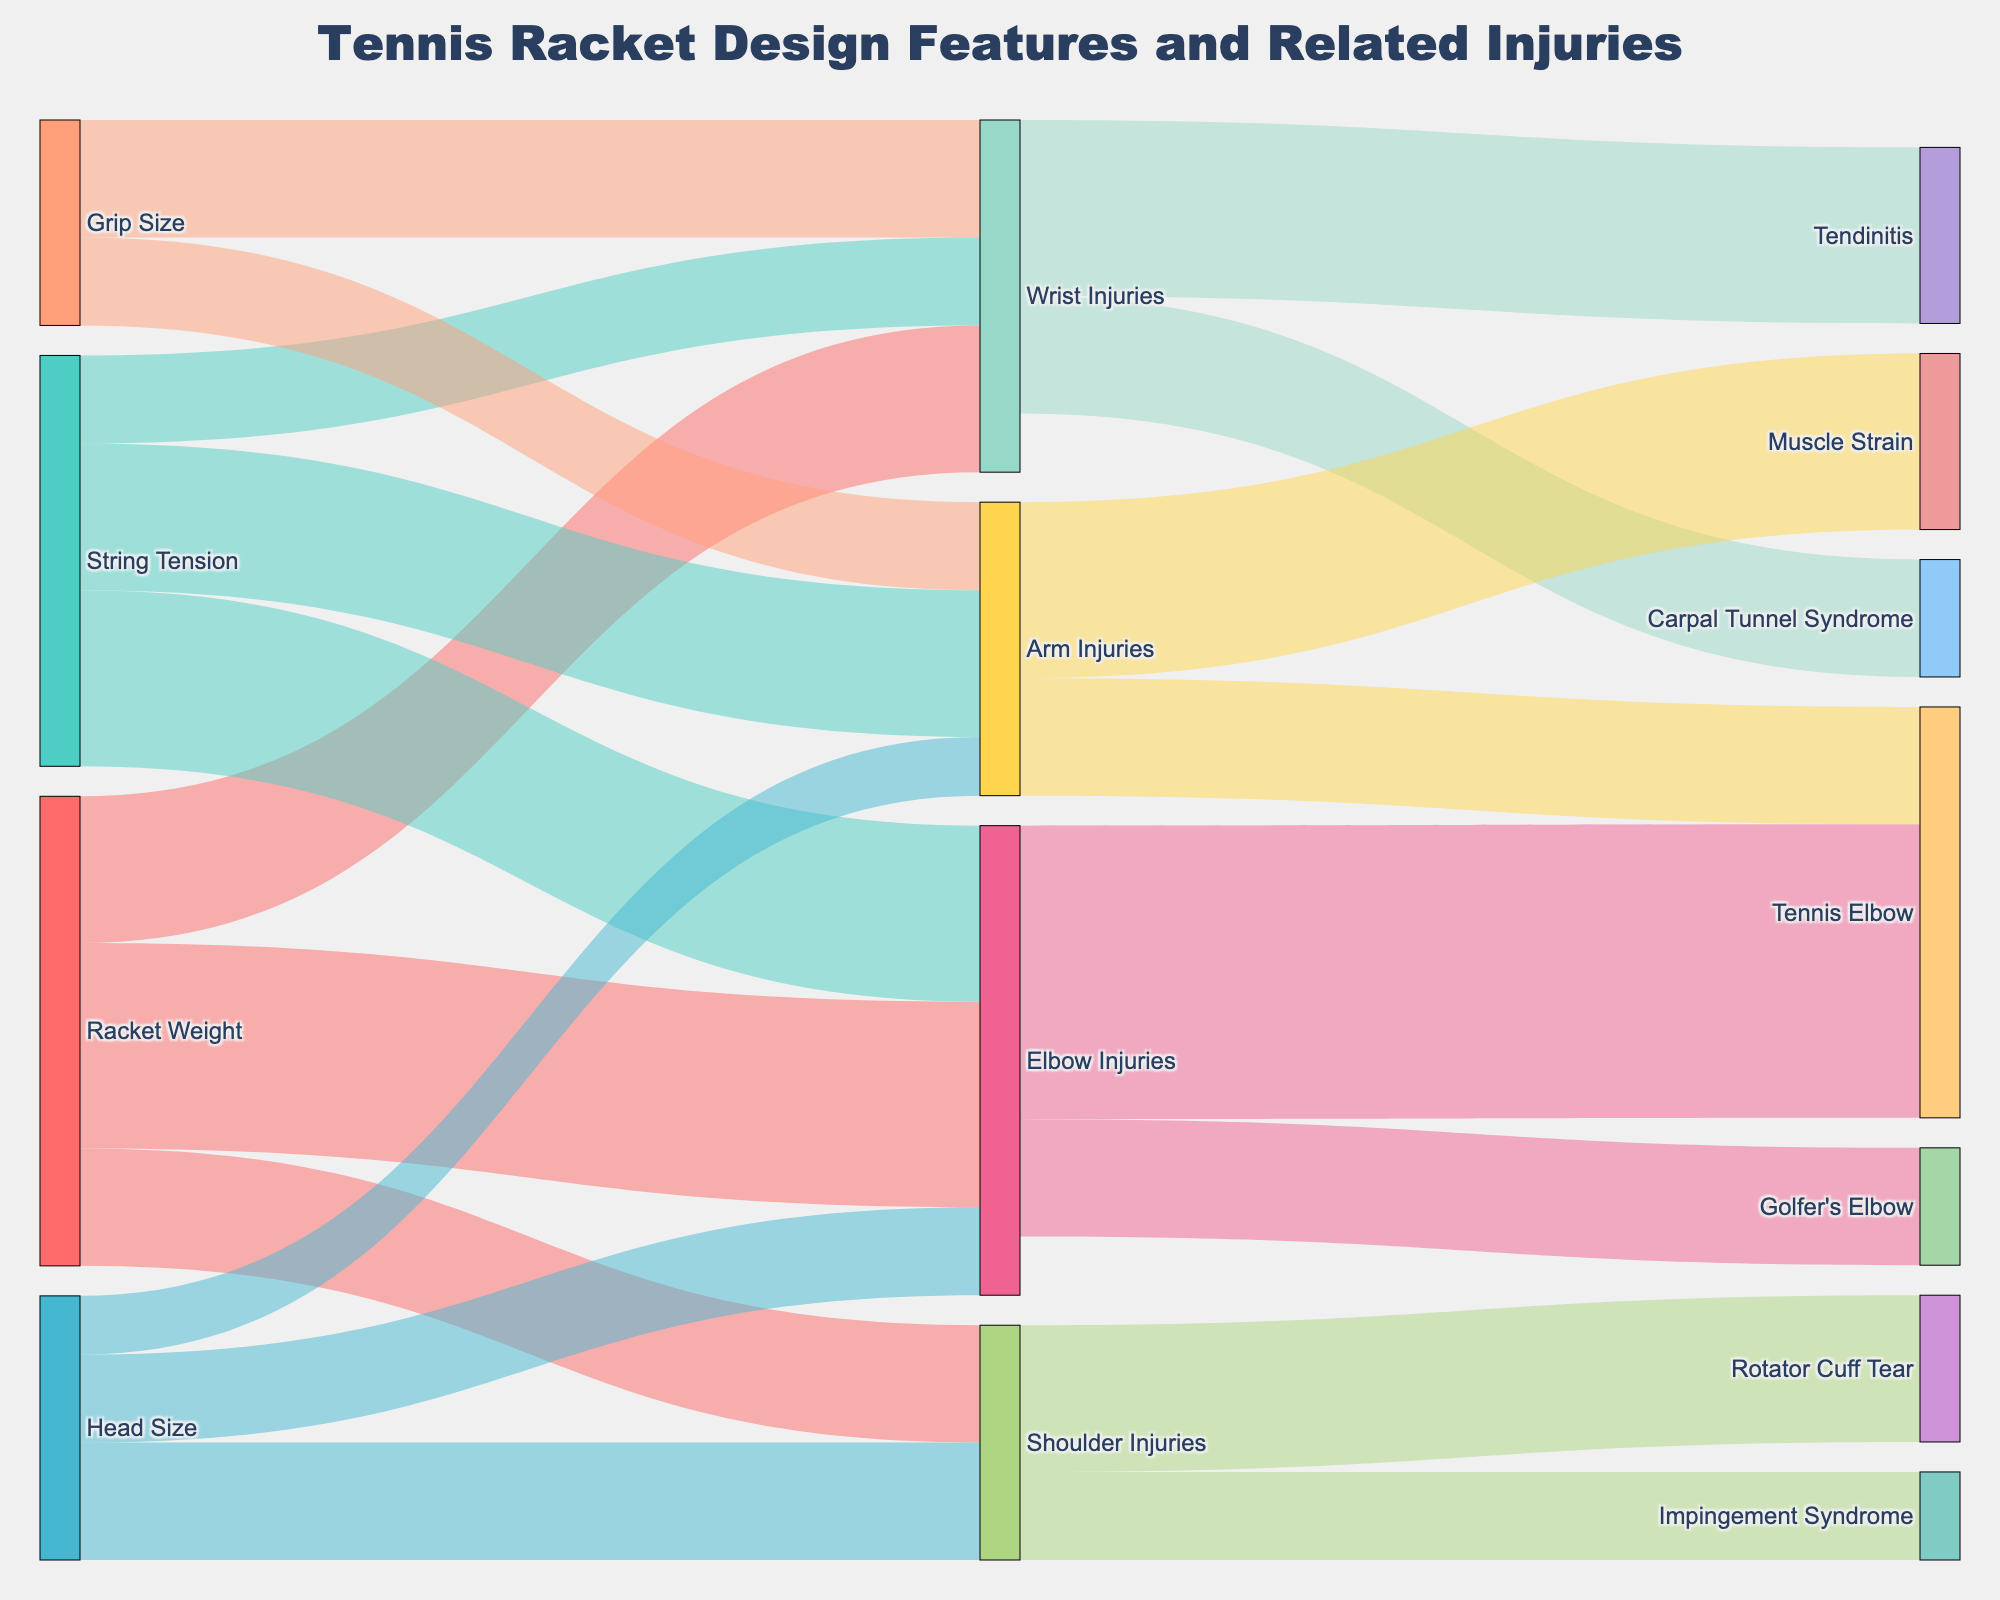How many injuries are related to String Tension? The sources that link to injuries related to String Tension are examined. Adding up the values for Elbow Injuries (30), Wrist Injuries (15), and Arm Injuries (25) results in a total of 70.
Answer: 70 Which injury type has the highest correlation with Racket Weight? The connections from Racket Weight to Wrist Injuries (25), Elbow Injuries (35), and Shoulder Injuries (20) are analyzed. Elbow Injuries have the highest value at 35.
Answer: Elbow Injuries How many types of elbow injuries are indicated in the diagram, and what are they? The target node Elbow Injuries splits into Tennis Elbow (50) and Golfer's Elbow (20), indicating two types.
Answer: Two types: Tennis Elbow and Golfer's Elbow Is String Tension more associated with Elbow Injuries or Shoulder Injuries? By noting that String Tension connects to Elbow Injuries (30) and seeing that there is no connection to Shoulder Injuries from String Tension, the comparison is straightforward.
Answer: Elbow Injuries What is the total number of injuries connected to Grip Size as a source? Adding the values from Grip Size to Wrist Injuries (20) and Arm Injuries (15) gives a total of 35.
Answer: 35 Which racket feature is least correlated with Shoulder Injuries? By comparing the values from each racket feature to Shoulder Injuries: Racket Weight (20), Head Size (20), and none from String Tension and Grip Size, both Racket Weight and Head Size have the least correlation equally.
Answer: Racket Weight, Head Size What percentage of Shoulder Injuries result in Rotator Cuff Tear? Examining the link from Shoulder Injuries to Rotator Cuff Tear (25) out of the total Shoulder Injuries (20 + 15 = 35), the percentage is (25/35) * 100 ≈ 71.4%.
Answer: 71.4% Which specific injury type has the highest value in the diagram? By comparing all target values, Tennis Elbow (50) has the highest value.
Answer: Tennis Elbow Do more injuries lead to Carpal Tunnel Syndrome or Impingement Syndrome? By comparing the values, Carpal Tunnel Syndrome (20) and Impingement Syndrome (15), Carpal Tunnel Syndrome has more injuries.
Answer: Carpal Tunnel Syndrome 